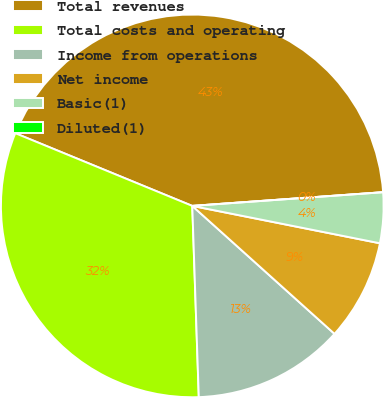Convert chart to OTSL. <chart><loc_0><loc_0><loc_500><loc_500><pie_chart><fcel>Total revenues<fcel>Total costs and operating<fcel>Income from operations<fcel>Net income<fcel>Basic(1)<fcel>Diluted(1)<nl><fcel>42.66%<fcel>31.75%<fcel>12.8%<fcel>8.53%<fcel>4.27%<fcel>0.0%<nl></chart> 